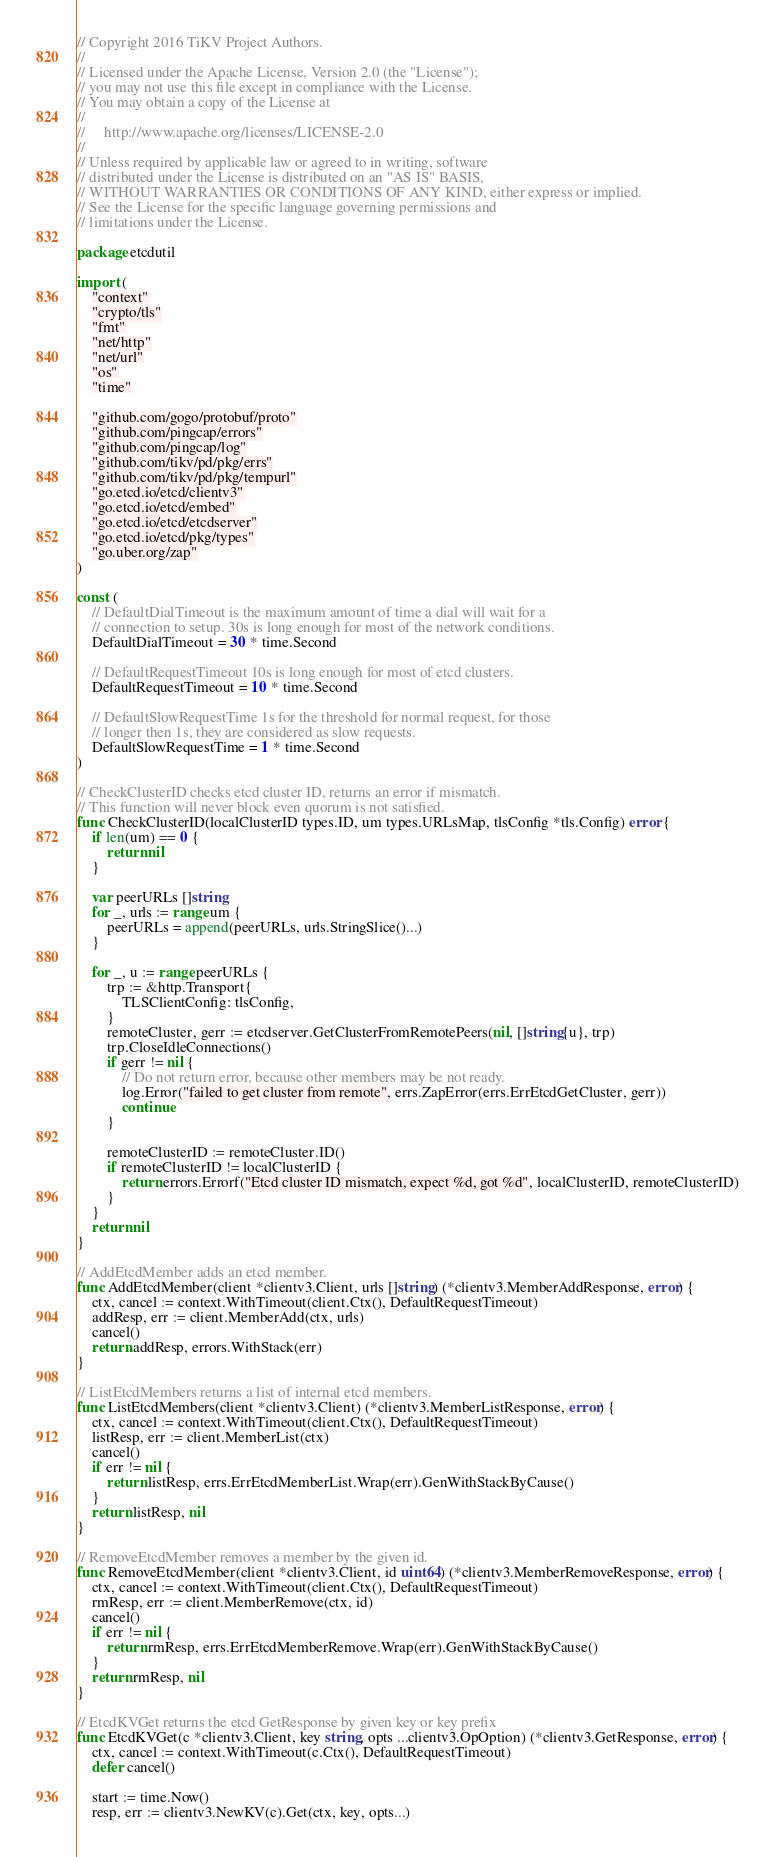<code> <loc_0><loc_0><loc_500><loc_500><_Go_>// Copyright 2016 TiKV Project Authors.
//
// Licensed under the Apache License, Version 2.0 (the "License");
// you may not use this file except in compliance with the License.
// You may obtain a copy of the License at
//
//     http://www.apache.org/licenses/LICENSE-2.0
//
// Unless required by applicable law or agreed to in writing, software
// distributed under the License is distributed on an "AS IS" BASIS,
// WITHOUT WARRANTIES OR CONDITIONS OF ANY KIND, either express or implied.
// See the License for the specific language governing permissions and
// limitations under the License.

package etcdutil

import (
	"context"
	"crypto/tls"
	"fmt"
	"net/http"
	"net/url"
	"os"
	"time"

	"github.com/gogo/protobuf/proto"
	"github.com/pingcap/errors"
	"github.com/pingcap/log"
	"github.com/tikv/pd/pkg/errs"
	"github.com/tikv/pd/pkg/tempurl"
	"go.etcd.io/etcd/clientv3"
	"go.etcd.io/etcd/embed"
	"go.etcd.io/etcd/etcdserver"
	"go.etcd.io/etcd/pkg/types"
	"go.uber.org/zap"
)

const (
	// DefaultDialTimeout is the maximum amount of time a dial will wait for a
	// connection to setup. 30s is long enough for most of the network conditions.
	DefaultDialTimeout = 30 * time.Second

	// DefaultRequestTimeout 10s is long enough for most of etcd clusters.
	DefaultRequestTimeout = 10 * time.Second

	// DefaultSlowRequestTime 1s for the threshold for normal request, for those
	// longer then 1s, they are considered as slow requests.
	DefaultSlowRequestTime = 1 * time.Second
)

// CheckClusterID checks etcd cluster ID, returns an error if mismatch.
// This function will never block even quorum is not satisfied.
func CheckClusterID(localClusterID types.ID, um types.URLsMap, tlsConfig *tls.Config) error {
	if len(um) == 0 {
		return nil
	}

	var peerURLs []string
	for _, urls := range um {
		peerURLs = append(peerURLs, urls.StringSlice()...)
	}

	for _, u := range peerURLs {
		trp := &http.Transport{
			TLSClientConfig: tlsConfig,
		}
		remoteCluster, gerr := etcdserver.GetClusterFromRemotePeers(nil, []string{u}, trp)
		trp.CloseIdleConnections()
		if gerr != nil {
			// Do not return error, because other members may be not ready.
			log.Error("failed to get cluster from remote", errs.ZapError(errs.ErrEtcdGetCluster, gerr))
			continue
		}

		remoteClusterID := remoteCluster.ID()
		if remoteClusterID != localClusterID {
			return errors.Errorf("Etcd cluster ID mismatch, expect %d, got %d", localClusterID, remoteClusterID)
		}
	}
	return nil
}

// AddEtcdMember adds an etcd member.
func AddEtcdMember(client *clientv3.Client, urls []string) (*clientv3.MemberAddResponse, error) {
	ctx, cancel := context.WithTimeout(client.Ctx(), DefaultRequestTimeout)
	addResp, err := client.MemberAdd(ctx, urls)
	cancel()
	return addResp, errors.WithStack(err)
}

// ListEtcdMembers returns a list of internal etcd members.
func ListEtcdMembers(client *clientv3.Client) (*clientv3.MemberListResponse, error) {
	ctx, cancel := context.WithTimeout(client.Ctx(), DefaultRequestTimeout)
	listResp, err := client.MemberList(ctx)
	cancel()
	if err != nil {
		return listResp, errs.ErrEtcdMemberList.Wrap(err).GenWithStackByCause()
	}
	return listResp, nil
}

// RemoveEtcdMember removes a member by the given id.
func RemoveEtcdMember(client *clientv3.Client, id uint64) (*clientv3.MemberRemoveResponse, error) {
	ctx, cancel := context.WithTimeout(client.Ctx(), DefaultRequestTimeout)
	rmResp, err := client.MemberRemove(ctx, id)
	cancel()
	if err != nil {
		return rmResp, errs.ErrEtcdMemberRemove.Wrap(err).GenWithStackByCause()
	}
	return rmResp, nil
}

// EtcdKVGet returns the etcd GetResponse by given key or key prefix
func EtcdKVGet(c *clientv3.Client, key string, opts ...clientv3.OpOption) (*clientv3.GetResponse, error) {
	ctx, cancel := context.WithTimeout(c.Ctx(), DefaultRequestTimeout)
	defer cancel()

	start := time.Now()
	resp, err := clientv3.NewKV(c).Get(ctx, key, opts...)</code> 